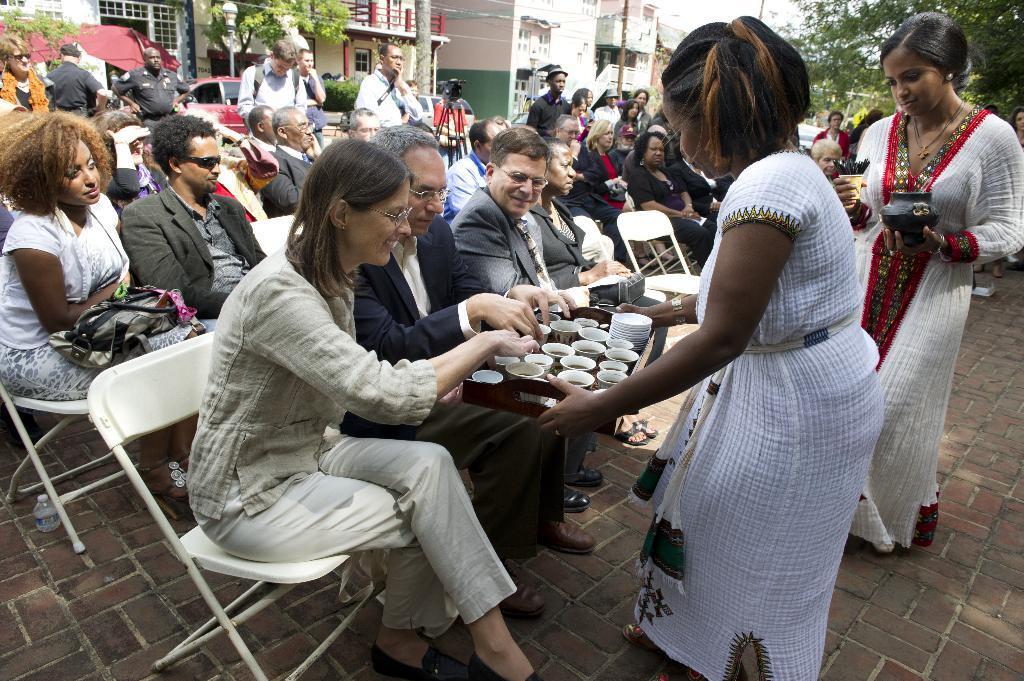In one or two sentences, can you explain what this image depicts? In this image there are group of persons siting on the chairs at the right side of the image there are two persons who are standing and at the background of the image there are buildings,trees. 